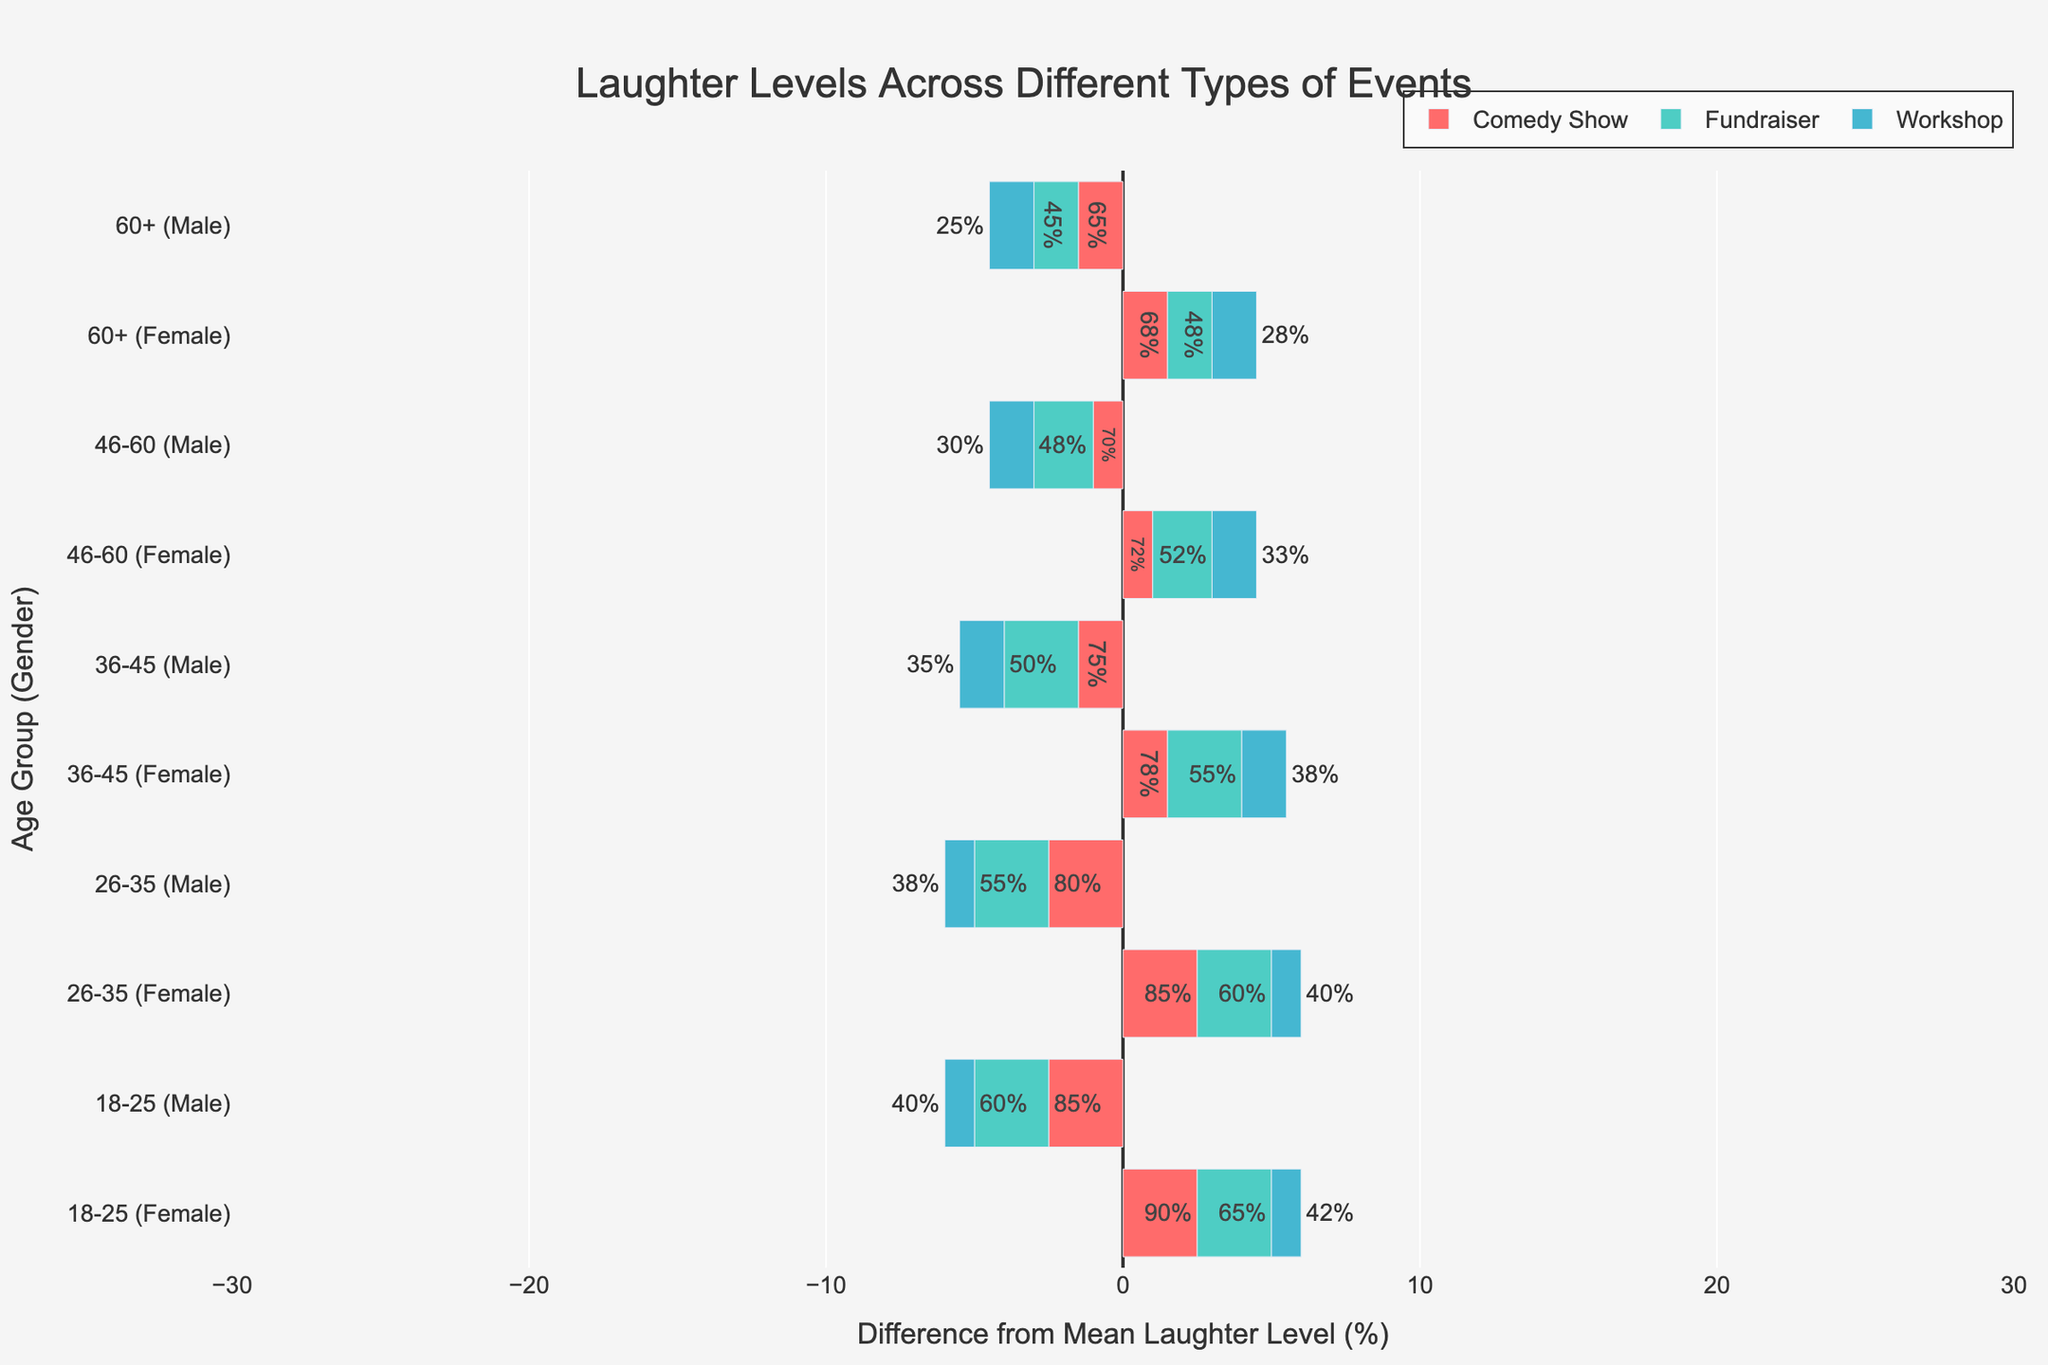Which event type generally has the highest laughter levels? From the colors of the bars, the red bars (Comedy Shows) representing laughter levels are generally higher than the green bars (Fundraisers) and blue bars (Workshops).
Answer: Comedy Shows How do laughter levels in Fundraisers compare between males and females in the 36-45 age group? Looking at the green bars for the 36-45 age group, females have a higher positioning than males, indicating higher laughter levels.
Answer: Females have higher laughter levels What is the overall trend in laughter levels as age increases for the Comedy Shows? Observing the red bars (Comedy Shows) from youngest to oldest age groups, the laughter levels generally decrease.
Answer: Decrease Which gender shows a greater decrease in laughter levels as age increases for Workshops? Blue bars (Workshops) show a greater difference in bar length for males compared to females when moving from younger to older age groups.
Answer: Males Compute the difference in laughter levels between the 18-25 and 46-60 age groups for Comedy Shows. For males: 85% (18-25) - 70% (46-60) = 15%. For females: 90% (18-25) - 72% (46-60) = 18%.
Answer: 15% (males), 18% (females) Do males or females have a higher average laughter level overall? By observing the prominence and positioning of bars across all colors indicating higher laughter levels, females generally have higher laughter levels compared to males.
Answer: Females 